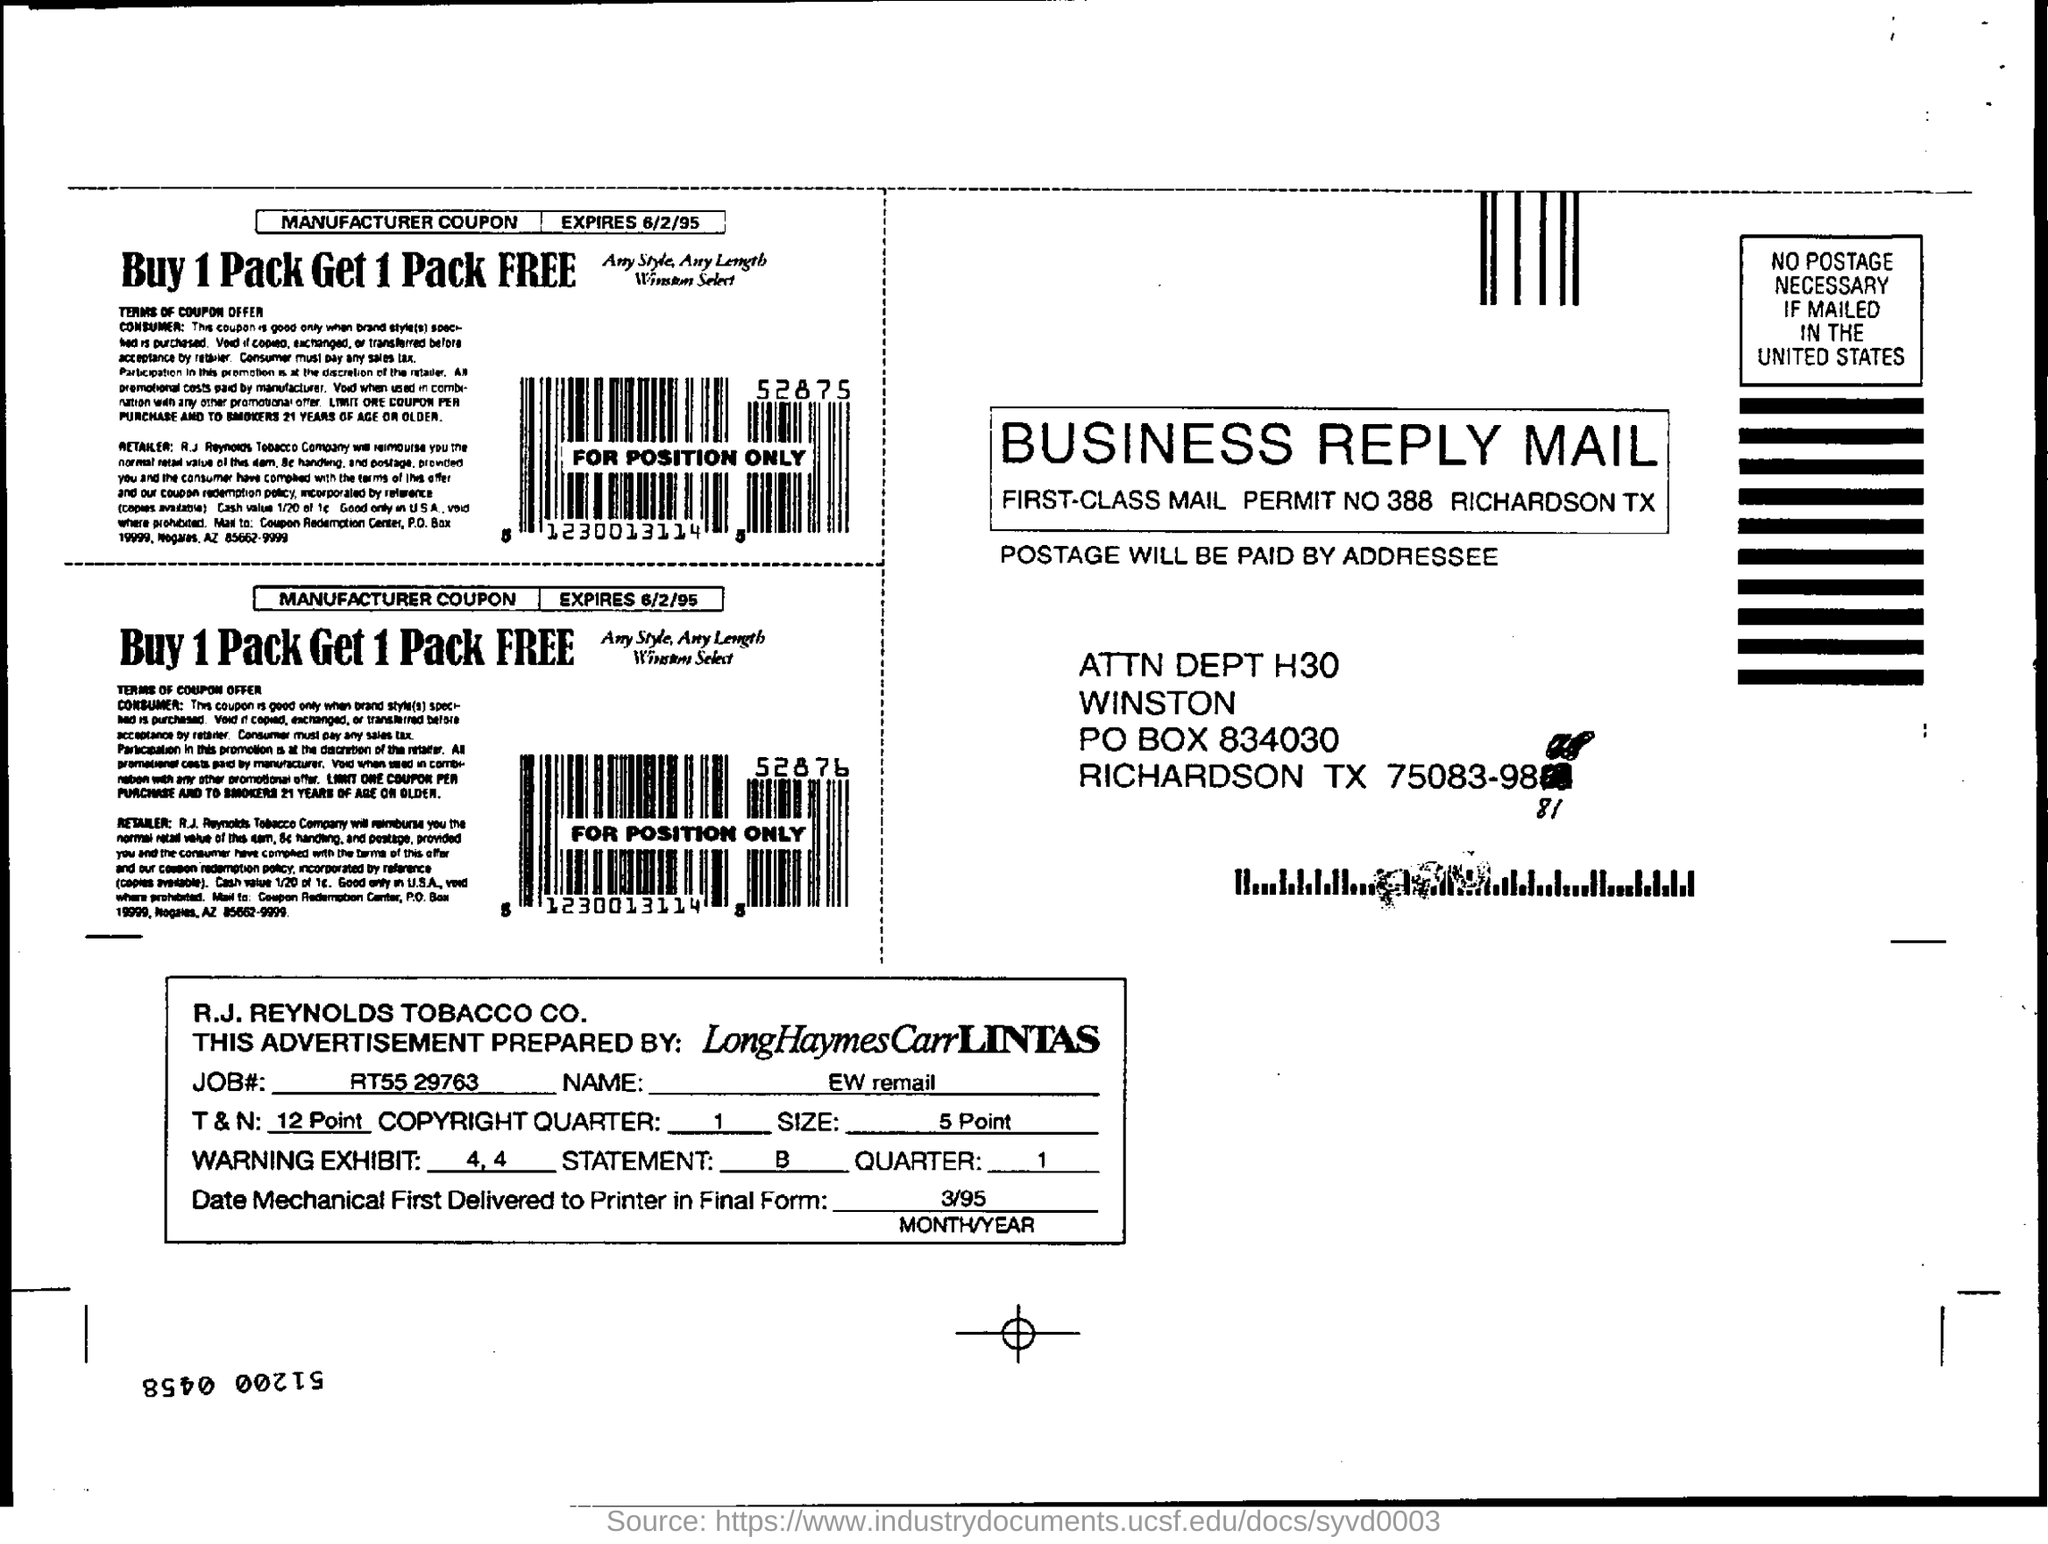By whom will be the postage paid?
Your answer should be compact. Addressee. Who has prepared the advertisement?
Ensure brevity in your answer.  LongHaymesCarrLINTAS. When was the mechanical first delivered to printer in final form?
Provide a short and direct response. 3/95. What is the job#?
Your answer should be very brief. RT55 29763. What is the permit number of the mail?
Make the answer very short. 388. What is the Job# mentioned in the advertisement?
Your answer should be very brief. RT55 29763. 